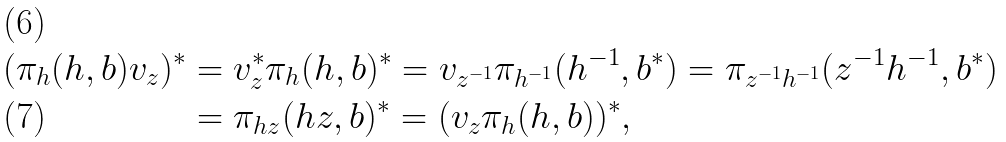Convert formula to latex. <formula><loc_0><loc_0><loc_500><loc_500>( \pi _ { h } ( h , b ) v _ { z } ) ^ { * } & = v _ { z } ^ { * } \pi _ { h } ( h , b ) ^ { * } = v _ { z ^ { - 1 } } \pi _ { h ^ { - 1 } } ( h ^ { - 1 } , b ^ { * } ) = \pi _ { z ^ { - 1 } h ^ { - 1 } } ( z ^ { - 1 } h ^ { - 1 } , b ^ { * } ) \\ & = \pi _ { h z } ( h z , b ) ^ { * } = ( v _ { z } \pi _ { h } ( h , b ) ) ^ { * } ,</formula> 